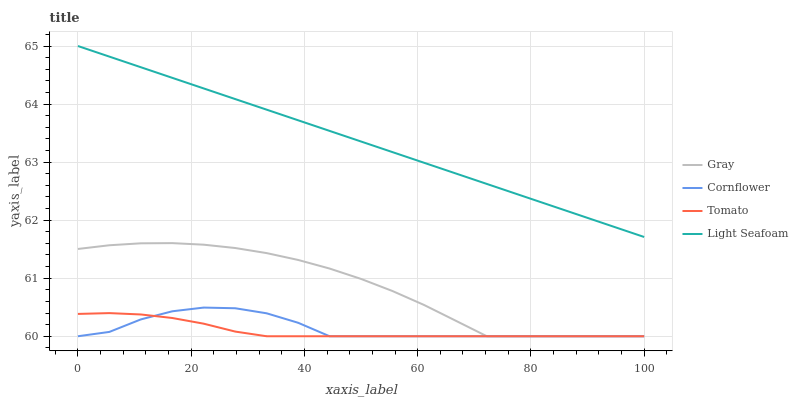Does Tomato have the minimum area under the curve?
Answer yes or no. Yes. Does Light Seafoam have the maximum area under the curve?
Answer yes or no. Yes. Does Gray have the minimum area under the curve?
Answer yes or no. No. Does Gray have the maximum area under the curve?
Answer yes or no. No. Is Light Seafoam the smoothest?
Answer yes or no. Yes. Is Cornflower the roughest?
Answer yes or no. Yes. Is Gray the smoothest?
Answer yes or no. No. Is Gray the roughest?
Answer yes or no. No. Does Tomato have the lowest value?
Answer yes or no. Yes. Does Light Seafoam have the lowest value?
Answer yes or no. No. Does Light Seafoam have the highest value?
Answer yes or no. Yes. Does Gray have the highest value?
Answer yes or no. No. Is Gray less than Light Seafoam?
Answer yes or no. Yes. Is Light Seafoam greater than Cornflower?
Answer yes or no. Yes. Does Cornflower intersect Gray?
Answer yes or no. Yes. Is Cornflower less than Gray?
Answer yes or no. No. Is Cornflower greater than Gray?
Answer yes or no. No. Does Gray intersect Light Seafoam?
Answer yes or no. No. 